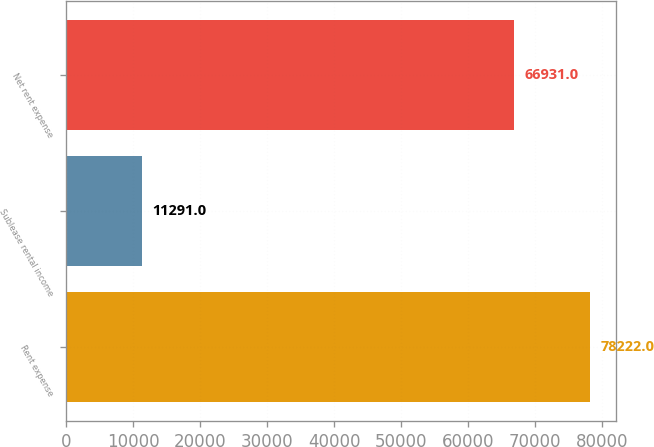<chart> <loc_0><loc_0><loc_500><loc_500><bar_chart><fcel>Rent expense<fcel>Sublease rental income<fcel>Net rent expense<nl><fcel>78222<fcel>11291<fcel>66931<nl></chart> 